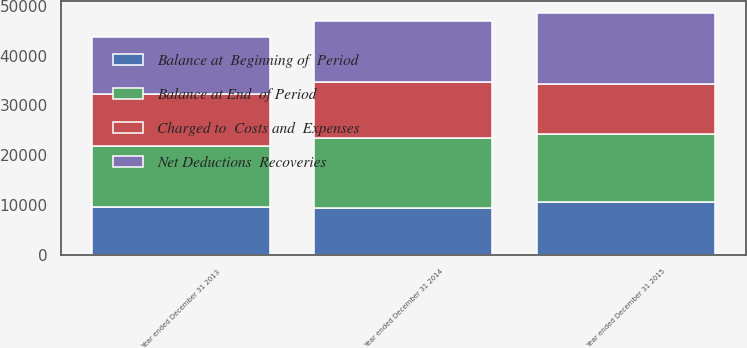Convert chart to OTSL. <chart><loc_0><loc_0><loc_500><loc_500><stacked_bar_chart><ecel><fcel>Year ended December 31 2015<fcel>Year ended December 31 2014<fcel>Year ended December 31 2013<nl><fcel>Net Deductions  Recoveries<fcel>14094<fcel>12278<fcel>11461<nl><fcel>Charged to  Costs and  Expenses<fcel>10113<fcel>11197<fcel>10388<nl><fcel>Balance at  Beginning of  Period<fcel>10571<fcel>9381<fcel>9571<nl><fcel>Balance at End  of Period<fcel>13636<fcel>14094<fcel>12278<nl></chart> 